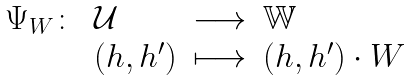<formula> <loc_0><loc_0><loc_500><loc_500>\begin{array} { l l l l } \Psi _ { W } \colon & \mathcal { U } & \longrightarrow & \mathbb { W } \\ & ( h , h ^ { \prime } ) & \longmapsto & ( h , h ^ { \prime } ) \cdot W \end{array}</formula> 